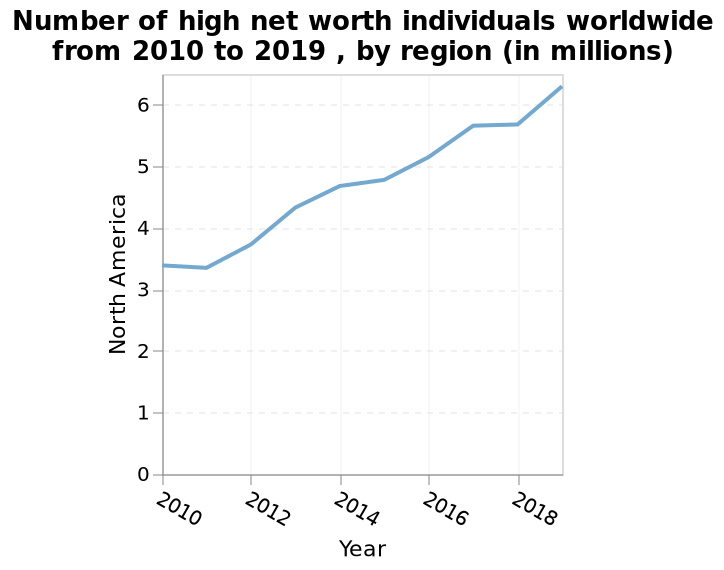<image>
Describe the following image in detail This is a line graph labeled Number of high net worth individuals worldwide from 2010 to 2019 , by region (in millions). A linear scale with a minimum of 0 and a maximum of 6 can be seen on the y-axis, marked North America. Year is shown along the x-axis. How has the number of high net worth individuals in North America changed between 2010 and 2019?  The number of high net worth individuals in North America has gradually increased between 2010 and 2019. What information does the x-axis display? The x-axis displays the years from 2010 to 2019. What does the y-axis represent in the line graph?  The y-axis represents the number of high net worth individuals worldwide, measured in millions. What is the title of the graph?  The graph is titled "Number of high net worth individuals worldwide from 2010 to 2019, by region". What is the range of values shown on the y-axis? The y-axis ranges from 0 million to 6 million. 